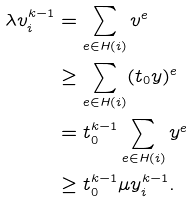<formula> <loc_0><loc_0><loc_500><loc_500>\lambda v _ { i } ^ { k - 1 } & = \sum _ { e \in H ( i ) } v ^ { e } \\ & \geq \sum _ { e \in H ( i ) } ( t _ { 0 } y ) ^ { e } \\ & = t _ { 0 } ^ { k - 1 } \sum _ { e \in H ( i ) } y ^ { e } \\ & \geq t _ { 0 } ^ { k - 1 } \mu y _ { i } ^ { k - 1 } .</formula> 